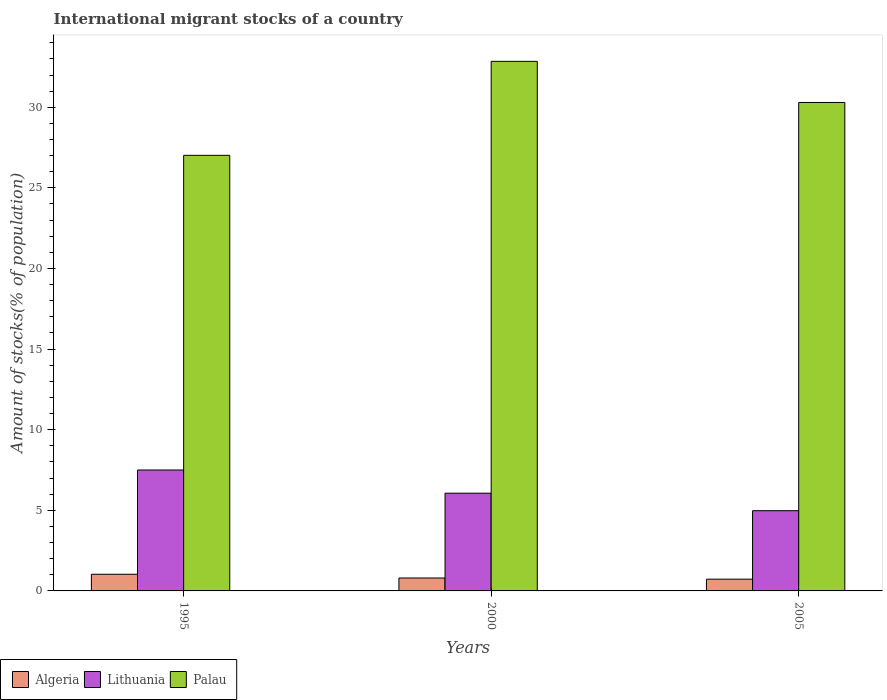How many groups of bars are there?
Offer a very short reply. 3. Are the number of bars on each tick of the X-axis equal?
Your answer should be very brief. Yes. How many bars are there on the 1st tick from the right?
Give a very brief answer. 3. In how many cases, is the number of bars for a given year not equal to the number of legend labels?
Provide a succinct answer. 0. What is the amount of stocks in in Lithuania in 2005?
Your answer should be very brief. 4.98. Across all years, what is the maximum amount of stocks in in Algeria?
Provide a short and direct response. 1.03. Across all years, what is the minimum amount of stocks in in Lithuania?
Your answer should be very brief. 4.98. In which year was the amount of stocks in in Lithuania maximum?
Keep it short and to the point. 1995. What is the total amount of stocks in in Lithuania in the graph?
Your response must be concise. 18.54. What is the difference between the amount of stocks in in Algeria in 2000 and that in 2005?
Keep it short and to the point. 0.07. What is the difference between the amount of stocks in in Algeria in 2000 and the amount of stocks in in Palau in 2005?
Offer a very short reply. -29.49. What is the average amount of stocks in in Lithuania per year?
Give a very brief answer. 6.18. In the year 2000, what is the difference between the amount of stocks in in Lithuania and amount of stocks in in Palau?
Offer a terse response. -26.78. What is the ratio of the amount of stocks in in Lithuania in 1995 to that in 2000?
Your answer should be compact. 1.24. What is the difference between the highest and the second highest amount of stocks in in Algeria?
Your answer should be compact. 0.23. What is the difference between the highest and the lowest amount of stocks in in Algeria?
Keep it short and to the point. 0.31. Is the sum of the amount of stocks in in Lithuania in 2000 and 2005 greater than the maximum amount of stocks in in Algeria across all years?
Make the answer very short. Yes. What does the 3rd bar from the left in 2005 represents?
Provide a succinct answer. Palau. What does the 2nd bar from the right in 1995 represents?
Provide a short and direct response. Lithuania. Is it the case that in every year, the sum of the amount of stocks in in Algeria and amount of stocks in in Palau is greater than the amount of stocks in in Lithuania?
Offer a very short reply. Yes. How many bars are there?
Your answer should be compact. 9. Are all the bars in the graph horizontal?
Give a very brief answer. No. How many years are there in the graph?
Make the answer very short. 3. Are the values on the major ticks of Y-axis written in scientific E-notation?
Your response must be concise. No. Where does the legend appear in the graph?
Ensure brevity in your answer.  Bottom left. How many legend labels are there?
Offer a very short reply. 3. What is the title of the graph?
Make the answer very short. International migrant stocks of a country. What is the label or title of the X-axis?
Your answer should be very brief. Years. What is the label or title of the Y-axis?
Keep it short and to the point. Amount of stocks(% of population). What is the Amount of stocks(% of population) in Algeria in 1995?
Provide a succinct answer. 1.03. What is the Amount of stocks(% of population) in Lithuania in 1995?
Offer a very short reply. 7.5. What is the Amount of stocks(% of population) of Palau in 1995?
Give a very brief answer. 27.02. What is the Amount of stocks(% of population) of Algeria in 2000?
Your answer should be very brief. 0.8. What is the Amount of stocks(% of population) in Lithuania in 2000?
Keep it short and to the point. 6.06. What is the Amount of stocks(% of population) of Palau in 2000?
Your answer should be very brief. 32.85. What is the Amount of stocks(% of population) of Algeria in 2005?
Make the answer very short. 0.73. What is the Amount of stocks(% of population) of Lithuania in 2005?
Your answer should be compact. 4.98. What is the Amount of stocks(% of population) in Palau in 2005?
Offer a terse response. 30.3. Across all years, what is the maximum Amount of stocks(% of population) in Algeria?
Give a very brief answer. 1.03. Across all years, what is the maximum Amount of stocks(% of population) of Lithuania?
Keep it short and to the point. 7.5. Across all years, what is the maximum Amount of stocks(% of population) of Palau?
Your response must be concise. 32.85. Across all years, what is the minimum Amount of stocks(% of population) in Algeria?
Offer a very short reply. 0.73. Across all years, what is the minimum Amount of stocks(% of population) in Lithuania?
Give a very brief answer. 4.98. Across all years, what is the minimum Amount of stocks(% of population) of Palau?
Offer a very short reply. 27.02. What is the total Amount of stocks(% of population) in Algeria in the graph?
Keep it short and to the point. 2.56. What is the total Amount of stocks(% of population) of Lithuania in the graph?
Give a very brief answer. 18.54. What is the total Amount of stocks(% of population) of Palau in the graph?
Offer a very short reply. 90.16. What is the difference between the Amount of stocks(% of population) of Algeria in 1995 and that in 2000?
Your answer should be compact. 0.23. What is the difference between the Amount of stocks(% of population) in Lithuania in 1995 and that in 2000?
Ensure brevity in your answer.  1.44. What is the difference between the Amount of stocks(% of population) in Palau in 1995 and that in 2000?
Give a very brief answer. -5.83. What is the difference between the Amount of stocks(% of population) of Algeria in 1995 and that in 2005?
Ensure brevity in your answer.  0.31. What is the difference between the Amount of stocks(% of population) in Lithuania in 1995 and that in 2005?
Give a very brief answer. 2.52. What is the difference between the Amount of stocks(% of population) in Palau in 1995 and that in 2005?
Make the answer very short. -3.28. What is the difference between the Amount of stocks(% of population) of Algeria in 2000 and that in 2005?
Provide a short and direct response. 0.07. What is the difference between the Amount of stocks(% of population) of Lithuania in 2000 and that in 2005?
Your response must be concise. 1.09. What is the difference between the Amount of stocks(% of population) in Palau in 2000 and that in 2005?
Make the answer very short. 2.55. What is the difference between the Amount of stocks(% of population) of Algeria in 1995 and the Amount of stocks(% of population) of Lithuania in 2000?
Make the answer very short. -5.03. What is the difference between the Amount of stocks(% of population) of Algeria in 1995 and the Amount of stocks(% of population) of Palau in 2000?
Provide a short and direct response. -31.81. What is the difference between the Amount of stocks(% of population) of Lithuania in 1995 and the Amount of stocks(% of population) of Palau in 2000?
Provide a succinct answer. -25.35. What is the difference between the Amount of stocks(% of population) of Algeria in 1995 and the Amount of stocks(% of population) of Lithuania in 2005?
Offer a very short reply. -3.94. What is the difference between the Amount of stocks(% of population) in Algeria in 1995 and the Amount of stocks(% of population) in Palau in 2005?
Keep it short and to the point. -29.26. What is the difference between the Amount of stocks(% of population) of Lithuania in 1995 and the Amount of stocks(% of population) of Palau in 2005?
Your response must be concise. -22.8. What is the difference between the Amount of stocks(% of population) in Algeria in 2000 and the Amount of stocks(% of population) in Lithuania in 2005?
Ensure brevity in your answer.  -4.17. What is the difference between the Amount of stocks(% of population) in Algeria in 2000 and the Amount of stocks(% of population) in Palau in 2005?
Ensure brevity in your answer.  -29.49. What is the difference between the Amount of stocks(% of population) in Lithuania in 2000 and the Amount of stocks(% of population) in Palau in 2005?
Offer a very short reply. -24.23. What is the average Amount of stocks(% of population) in Algeria per year?
Offer a terse response. 0.85. What is the average Amount of stocks(% of population) of Lithuania per year?
Provide a succinct answer. 6.18. What is the average Amount of stocks(% of population) of Palau per year?
Make the answer very short. 30.05. In the year 1995, what is the difference between the Amount of stocks(% of population) in Algeria and Amount of stocks(% of population) in Lithuania?
Your answer should be very brief. -6.47. In the year 1995, what is the difference between the Amount of stocks(% of population) of Algeria and Amount of stocks(% of population) of Palau?
Your answer should be very brief. -25.98. In the year 1995, what is the difference between the Amount of stocks(% of population) in Lithuania and Amount of stocks(% of population) in Palau?
Make the answer very short. -19.52. In the year 2000, what is the difference between the Amount of stocks(% of population) in Algeria and Amount of stocks(% of population) in Lithuania?
Ensure brevity in your answer.  -5.26. In the year 2000, what is the difference between the Amount of stocks(% of population) in Algeria and Amount of stocks(% of population) in Palau?
Give a very brief answer. -32.04. In the year 2000, what is the difference between the Amount of stocks(% of population) in Lithuania and Amount of stocks(% of population) in Palau?
Keep it short and to the point. -26.78. In the year 2005, what is the difference between the Amount of stocks(% of population) of Algeria and Amount of stocks(% of population) of Lithuania?
Give a very brief answer. -4.25. In the year 2005, what is the difference between the Amount of stocks(% of population) of Algeria and Amount of stocks(% of population) of Palau?
Offer a very short reply. -29.57. In the year 2005, what is the difference between the Amount of stocks(% of population) of Lithuania and Amount of stocks(% of population) of Palau?
Provide a succinct answer. -25.32. What is the ratio of the Amount of stocks(% of population) of Algeria in 1995 to that in 2000?
Keep it short and to the point. 1.29. What is the ratio of the Amount of stocks(% of population) of Lithuania in 1995 to that in 2000?
Offer a terse response. 1.24. What is the ratio of the Amount of stocks(% of population) of Palau in 1995 to that in 2000?
Your response must be concise. 0.82. What is the ratio of the Amount of stocks(% of population) of Algeria in 1995 to that in 2005?
Give a very brief answer. 1.42. What is the ratio of the Amount of stocks(% of population) of Lithuania in 1995 to that in 2005?
Offer a very short reply. 1.51. What is the ratio of the Amount of stocks(% of population) in Palau in 1995 to that in 2005?
Offer a terse response. 0.89. What is the ratio of the Amount of stocks(% of population) of Algeria in 2000 to that in 2005?
Provide a short and direct response. 1.1. What is the ratio of the Amount of stocks(% of population) of Lithuania in 2000 to that in 2005?
Your response must be concise. 1.22. What is the ratio of the Amount of stocks(% of population) of Palau in 2000 to that in 2005?
Offer a terse response. 1.08. What is the difference between the highest and the second highest Amount of stocks(% of population) in Algeria?
Provide a short and direct response. 0.23. What is the difference between the highest and the second highest Amount of stocks(% of population) in Lithuania?
Give a very brief answer. 1.44. What is the difference between the highest and the second highest Amount of stocks(% of population) of Palau?
Provide a short and direct response. 2.55. What is the difference between the highest and the lowest Amount of stocks(% of population) in Algeria?
Ensure brevity in your answer.  0.31. What is the difference between the highest and the lowest Amount of stocks(% of population) of Lithuania?
Your answer should be very brief. 2.52. What is the difference between the highest and the lowest Amount of stocks(% of population) in Palau?
Provide a short and direct response. 5.83. 